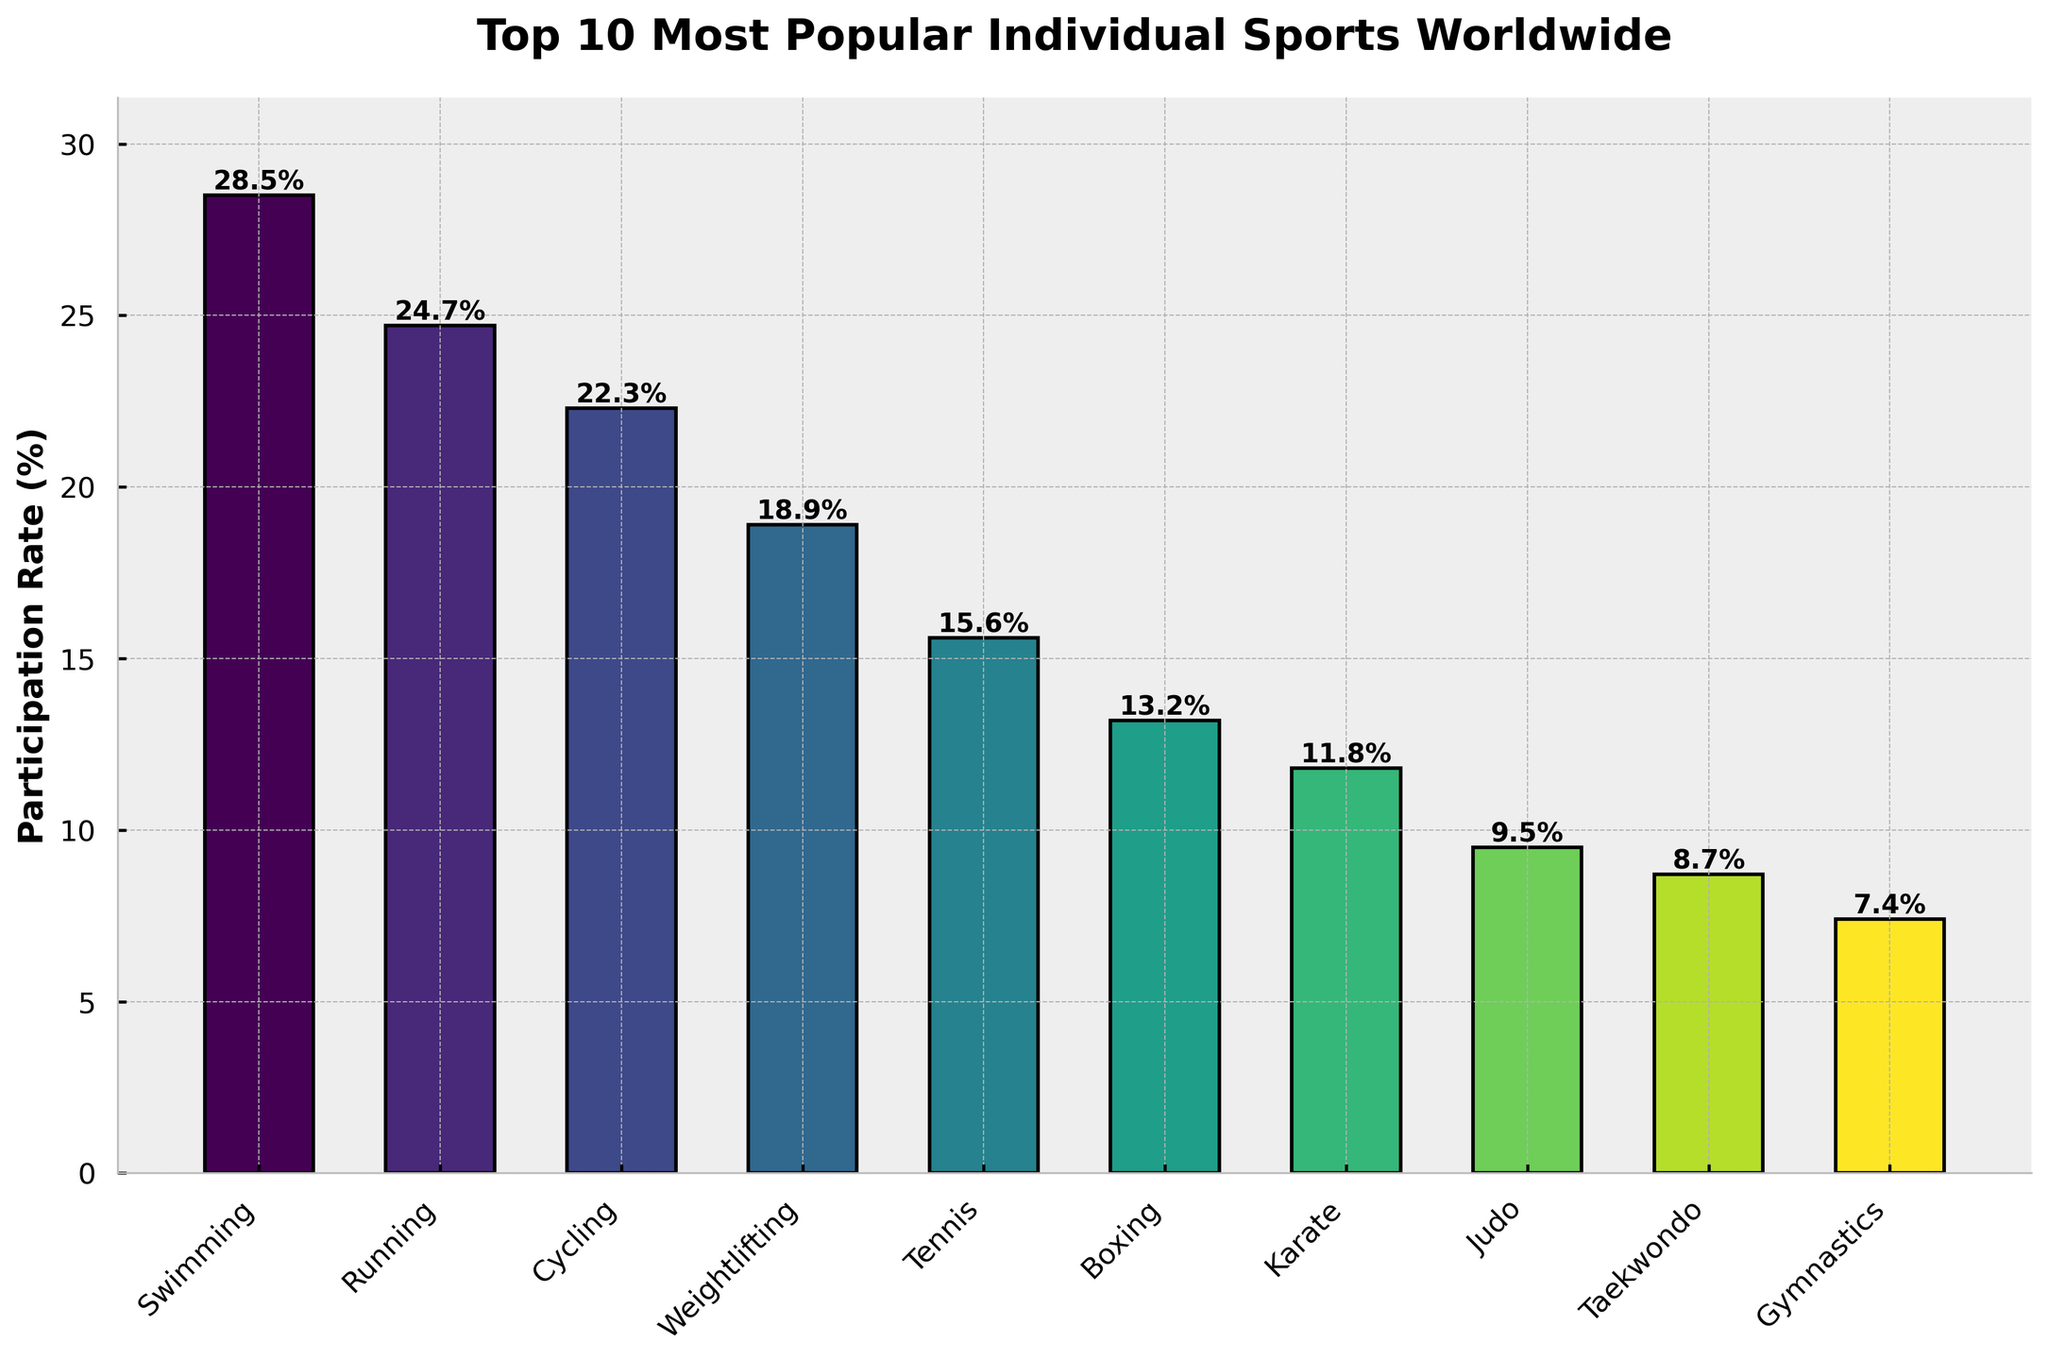What is the most popular individual sport based on participation rates? The bar showing the participation rate for Swimming is the tallest among all the bars. This indicates that Swimming has the highest participation rate.
Answer: Swimming Which sport has a higher participation rate, Running or Cycling? By comparing the heights of the bars corresponding to Running and Cycling, we see that the bar for Running is taller. Running has a participation rate of 24.7%, while Cycling has 22.3%.
Answer: Running What is the difference in participation rates between Tennis and Boxing? The participation rate for Tennis is 15.6%, and for Boxing, it's 13.2%. Subtracting the participation rate of Boxing from that of Tennis gives 15.6% - 13.2% = 2.4%.
Answer: 2.4% Which sport ranks just above Karate in terms of participation rate? In the plot, Boxing has a taller bar than Karate and is positioned directly above it in the ranking. Boxing has a higher participation rate of 13.2% compared to Karate's 11.8%.
Answer: Boxing What is the sum of participation rates for weightlifting and gymnastics? The participation rate for Weightlifting is 18.9% and for Gymnastics, it is 7.4%. Adding these together gives 18.9% + 7.4% = 26.3%.
Answer: 26.3% Which sport has the lower participation rate, Judo or Taekwondo? Comparing the heights of the bars for Judo and Taekwondo, we see that the bar for Taekwondo is shorter. Judo has a participation rate of 9.5% and Taekwondo has 8.7%.
Answer: Taekwondo Between Swimming and Running, which sport has a participation rate closer to 25%? The participation rate for Swimming is 28.5% and for Running, it is 24.7%. Since 24.7% is closer to 25% than 28.5%, Running has a participation rate closer to 25%.
Answer: Running How much taller is the bar for Cycling compared to Gymnastics? The participation rate for Cycling is 22.3%, and for Gymnastics, it is 7.4%. The difference in height between the two bars is 22.3% - 7.4% = 14.9%.
Answer: 14.9% What is the average participation rate of the top 3 sports? The top 3 sports by participation rates are Swimming (28.5%), Running (24.7%), and Cycling (22.3%). The average participation rate is calculated as (28.5% + 24.7% + 22.3%) / 3 = 25.16%.
Answer: 25.16% Which sport has the closest participation rate to that of Karate? The participation rate for Karate is 11.8%. By comparing the participation rates visually, Judo, with a participation rate of 9.5%, is the closest to Karate.
Answer: Judo 